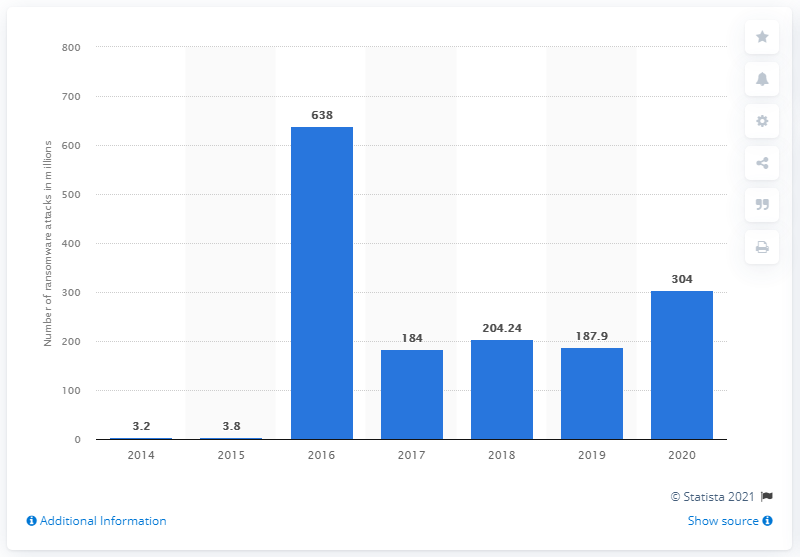Mention a couple of crucial points in this snapshot. In 2020, there were 304 reported ransomware attacks worldwide. There were 638 ransomware attacks in 2016. 